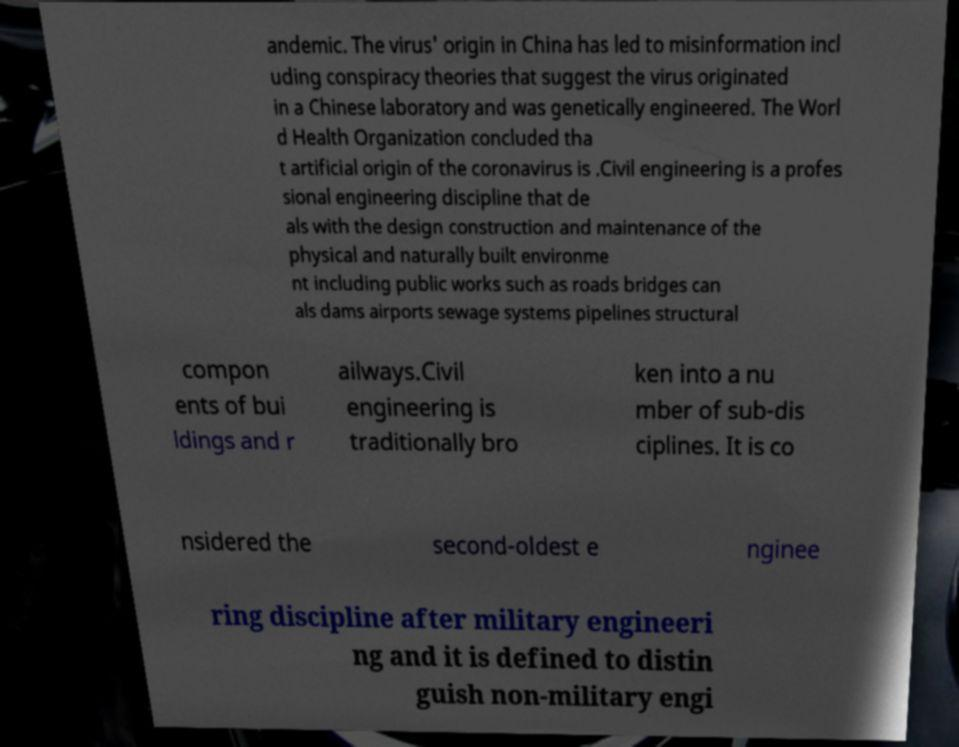Could you assist in decoding the text presented in this image and type it out clearly? andemic. The virus' origin in China has led to misinformation incl uding conspiracy theories that suggest the virus originated in a Chinese laboratory and was genetically engineered. The Worl d Health Organization concluded tha t artificial origin of the coronavirus is .Civil engineering is a profes sional engineering discipline that de als with the design construction and maintenance of the physical and naturally built environme nt including public works such as roads bridges can als dams airports sewage systems pipelines structural compon ents of bui ldings and r ailways.Civil engineering is traditionally bro ken into a nu mber of sub-dis ciplines. It is co nsidered the second-oldest e nginee ring discipline after military engineeri ng and it is defined to distin guish non-military engi 